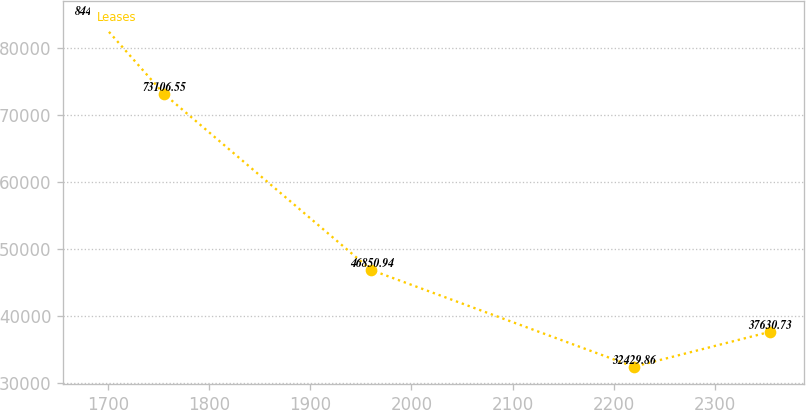<chart> <loc_0><loc_0><loc_500><loc_500><line_chart><ecel><fcel>Leases<nl><fcel>1688.61<fcel>84438.6<nl><fcel>1755.19<fcel>73106.6<nl><fcel>1960.16<fcel>46850.9<nl><fcel>2219.86<fcel>32429.9<nl><fcel>2354.46<fcel>37630.7<nl></chart> 